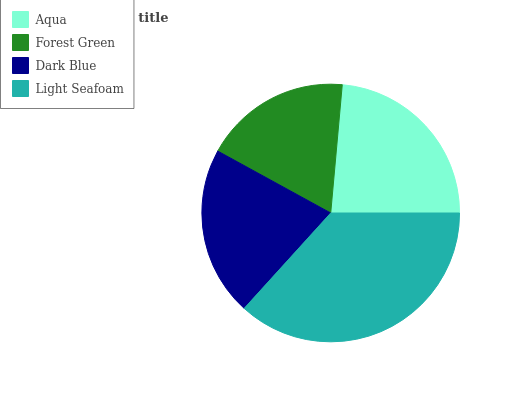Is Forest Green the minimum?
Answer yes or no. Yes. Is Light Seafoam the maximum?
Answer yes or no. Yes. Is Dark Blue the minimum?
Answer yes or no. No. Is Dark Blue the maximum?
Answer yes or no. No. Is Dark Blue greater than Forest Green?
Answer yes or no. Yes. Is Forest Green less than Dark Blue?
Answer yes or no. Yes. Is Forest Green greater than Dark Blue?
Answer yes or no. No. Is Dark Blue less than Forest Green?
Answer yes or no. No. Is Aqua the high median?
Answer yes or no. Yes. Is Dark Blue the low median?
Answer yes or no. Yes. Is Light Seafoam the high median?
Answer yes or no. No. Is Forest Green the low median?
Answer yes or no. No. 